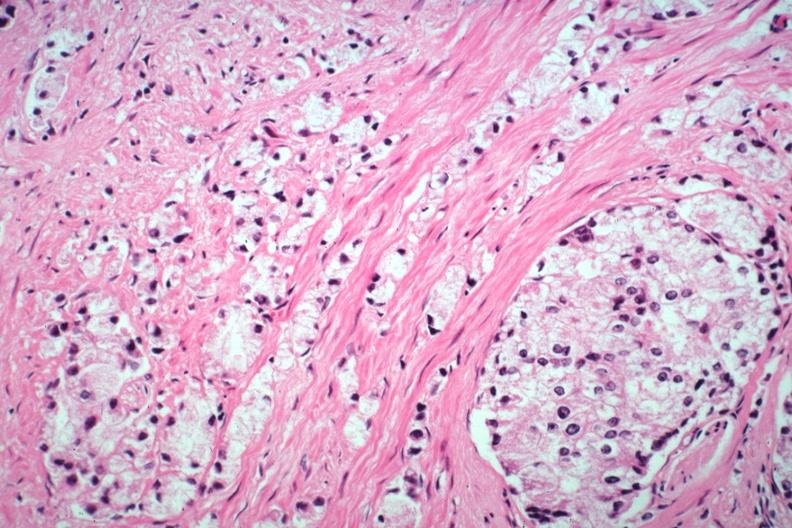what is present?
Answer the question using a single word or phrase. Prostate 